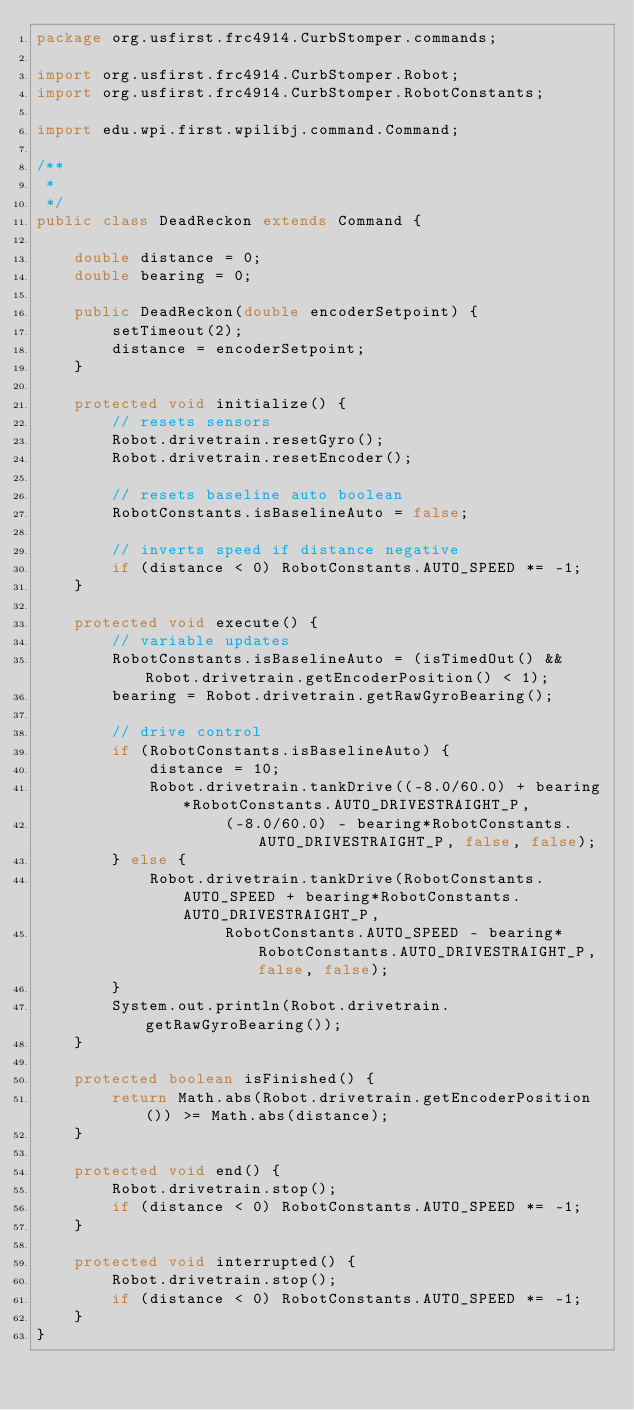Convert code to text. <code><loc_0><loc_0><loc_500><loc_500><_Java_>package org.usfirst.frc4914.CurbStomper.commands;

import org.usfirst.frc4914.CurbStomper.Robot;
import org.usfirst.frc4914.CurbStomper.RobotConstants;

import edu.wpi.first.wpilibj.command.Command;

/**
 *
 */
public class DeadReckon extends Command {
	
	double distance = 0;
	double bearing = 0;

    public DeadReckon(double encoderSetpoint) {
    	setTimeout(2);
    	distance = encoderSetpoint;
    }

    protected void initialize() {
    	// resets sensors
    	Robot.drivetrain.resetGyro();
    	Robot.drivetrain.resetEncoder();
    	
    	// resets baseline auto boolean
    	RobotConstants.isBaselineAuto = false;
    	
    	// inverts speed if distance negative
    	if (distance < 0) RobotConstants.AUTO_SPEED *= -1;
    }

    protected void execute() {
    	// variable updates
    	RobotConstants.isBaselineAuto = (isTimedOut() && Robot.drivetrain.getEncoderPosition() < 1);
    	bearing = Robot.drivetrain.getRawGyroBearing();
    	
    	// drive control
    	if (RobotConstants.isBaselineAuto) {
    		distance = 10;
    		Robot.drivetrain.tankDrive((-8.0/60.0) + bearing*RobotConstants.AUTO_DRIVESTRAIGHT_P, 
    				(-8.0/60.0) - bearing*RobotConstants.AUTO_DRIVESTRAIGHT_P, false, false);
    	} else {
    		Robot.drivetrain.tankDrive(RobotConstants.AUTO_SPEED + bearing*RobotConstants.AUTO_DRIVESTRAIGHT_P, 
    				RobotConstants.AUTO_SPEED - bearing*RobotConstants.AUTO_DRIVESTRAIGHT_P, false, false);
    	}
    	System.out.println(Robot.drivetrain.getRawGyroBearing());
    }

    protected boolean isFinished() {
        return Math.abs(Robot.drivetrain.getEncoderPosition()) >= Math.abs(distance);
    }

    protected void end() {
    	Robot.drivetrain.stop();
    	if (distance < 0) RobotConstants.AUTO_SPEED *= -1;
    }

    protected void interrupted() {
    	Robot.drivetrain.stop();
    	if (distance < 0) RobotConstants.AUTO_SPEED *= -1;
    }
}
</code> 